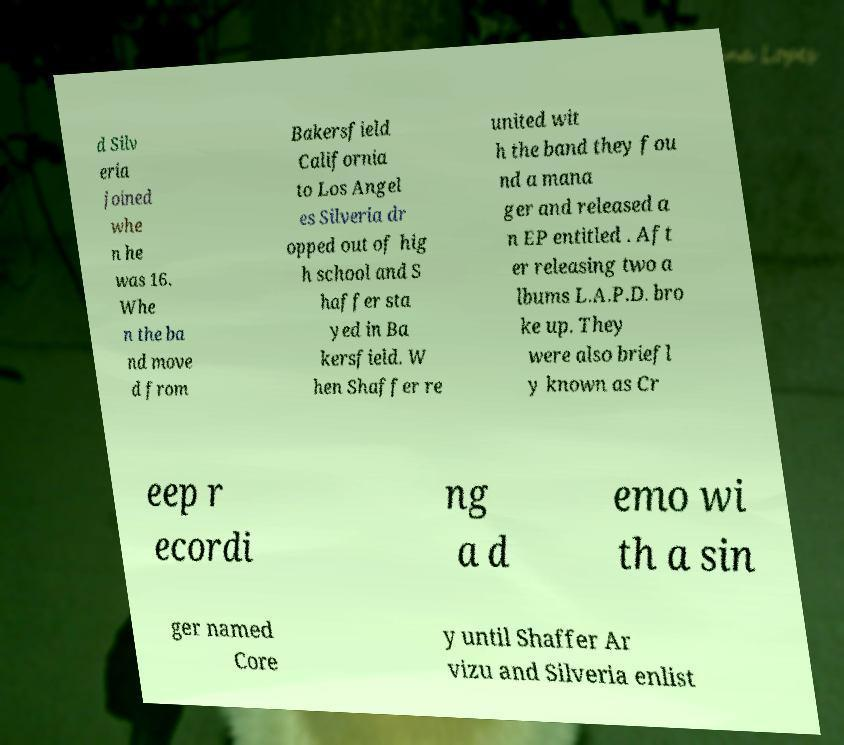Could you assist in decoding the text presented in this image and type it out clearly? d Silv eria joined whe n he was 16. Whe n the ba nd move d from Bakersfield California to Los Angel es Silveria dr opped out of hig h school and S haffer sta yed in Ba kersfield. W hen Shaffer re united wit h the band they fou nd a mana ger and released a n EP entitled . Aft er releasing two a lbums L.A.P.D. bro ke up. They were also briefl y known as Cr eep r ecordi ng a d emo wi th a sin ger named Core y until Shaffer Ar vizu and Silveria enlist 